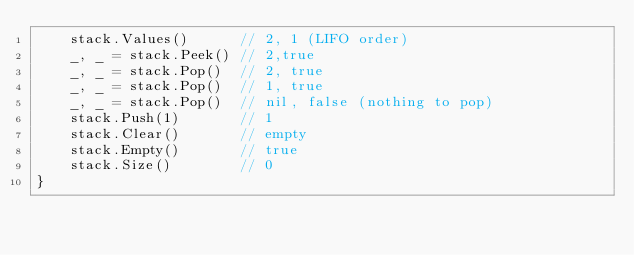Convert code to text. <code><loc_0><loc_0><loc_500><loc_500><_Go_>	stack.Values()      // 2, 1 (LIFO order)
	_, _ = stack.Peek() // 2,true
	_, _ = stack.Pop()  // 2, true
	_, _ = stack.Pop()  // 1, true
	_, _ = stack.Pop()  // nil, false (nothing to pop)
	stack.Push(1)       // 1
	stack.Clear()       // empty
	stack.Empty()       // true
	stack.Size()        // 0
}
</code> 